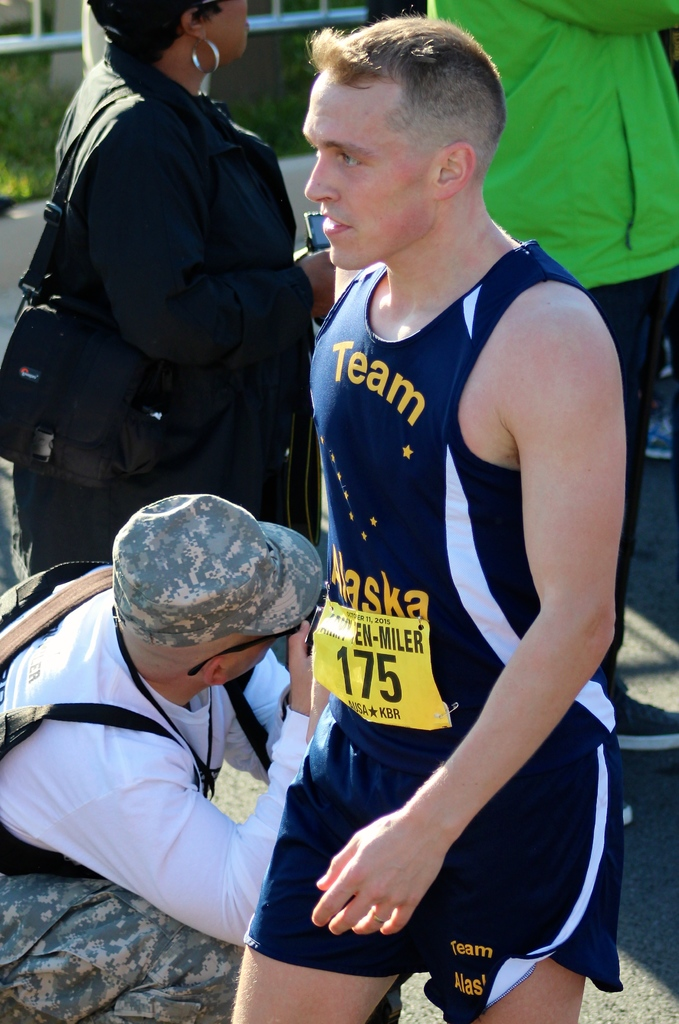Provide a one-sentence caption for the provided image. A focused athlete in a Team Alaska running outfit, numbered 175, receives medical attention during a race, highlighting the physical demands of competitive sports. 